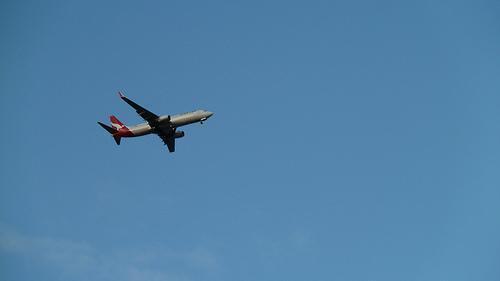How many planes are visible?
Give a very brief answer. 1. How many engines are shown on the plane?
Give a very brief answer. 2. 